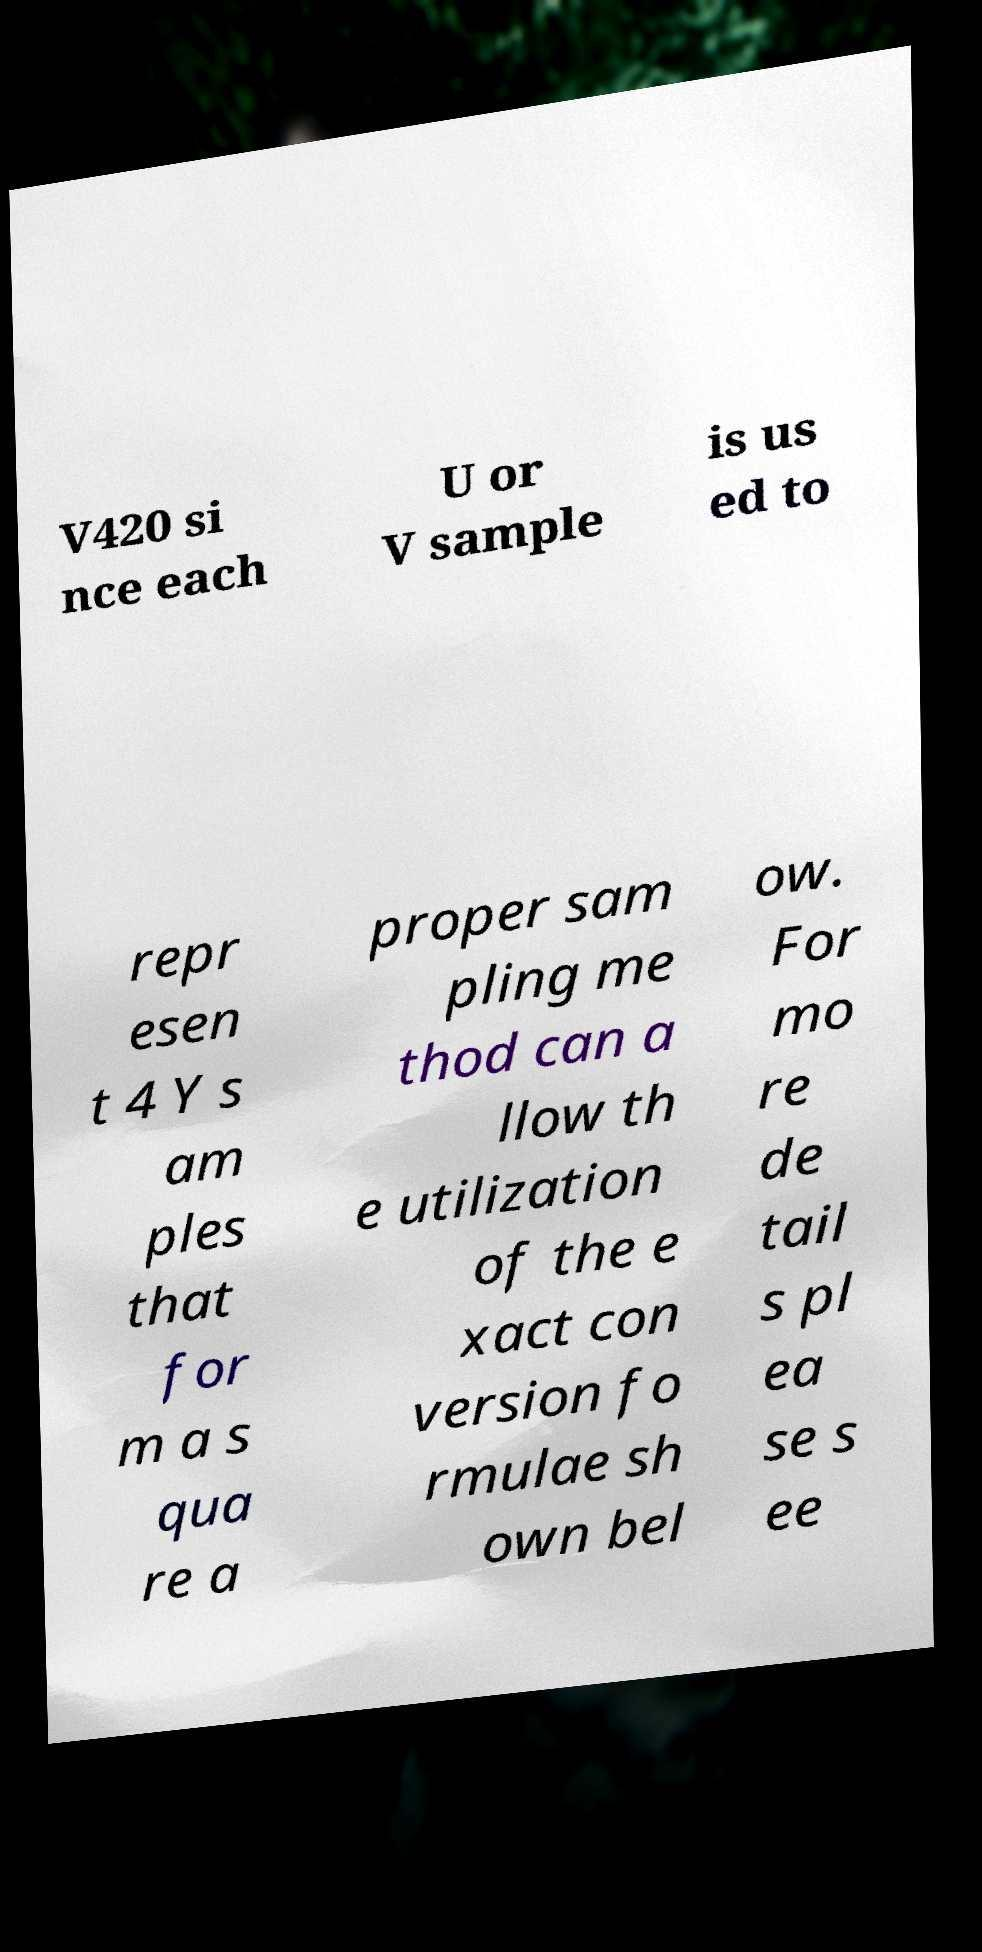Please identify and transcribe the text found in this image. V420 si nce each U or V sample is us ed to repr esen t 4 Y s am ples that for m a s qua re a proper sam pling me thod can a llow th e utilization of the e xact con version fo rmulae sh own bel ow. For mo re de tail s pl ea se s ee 